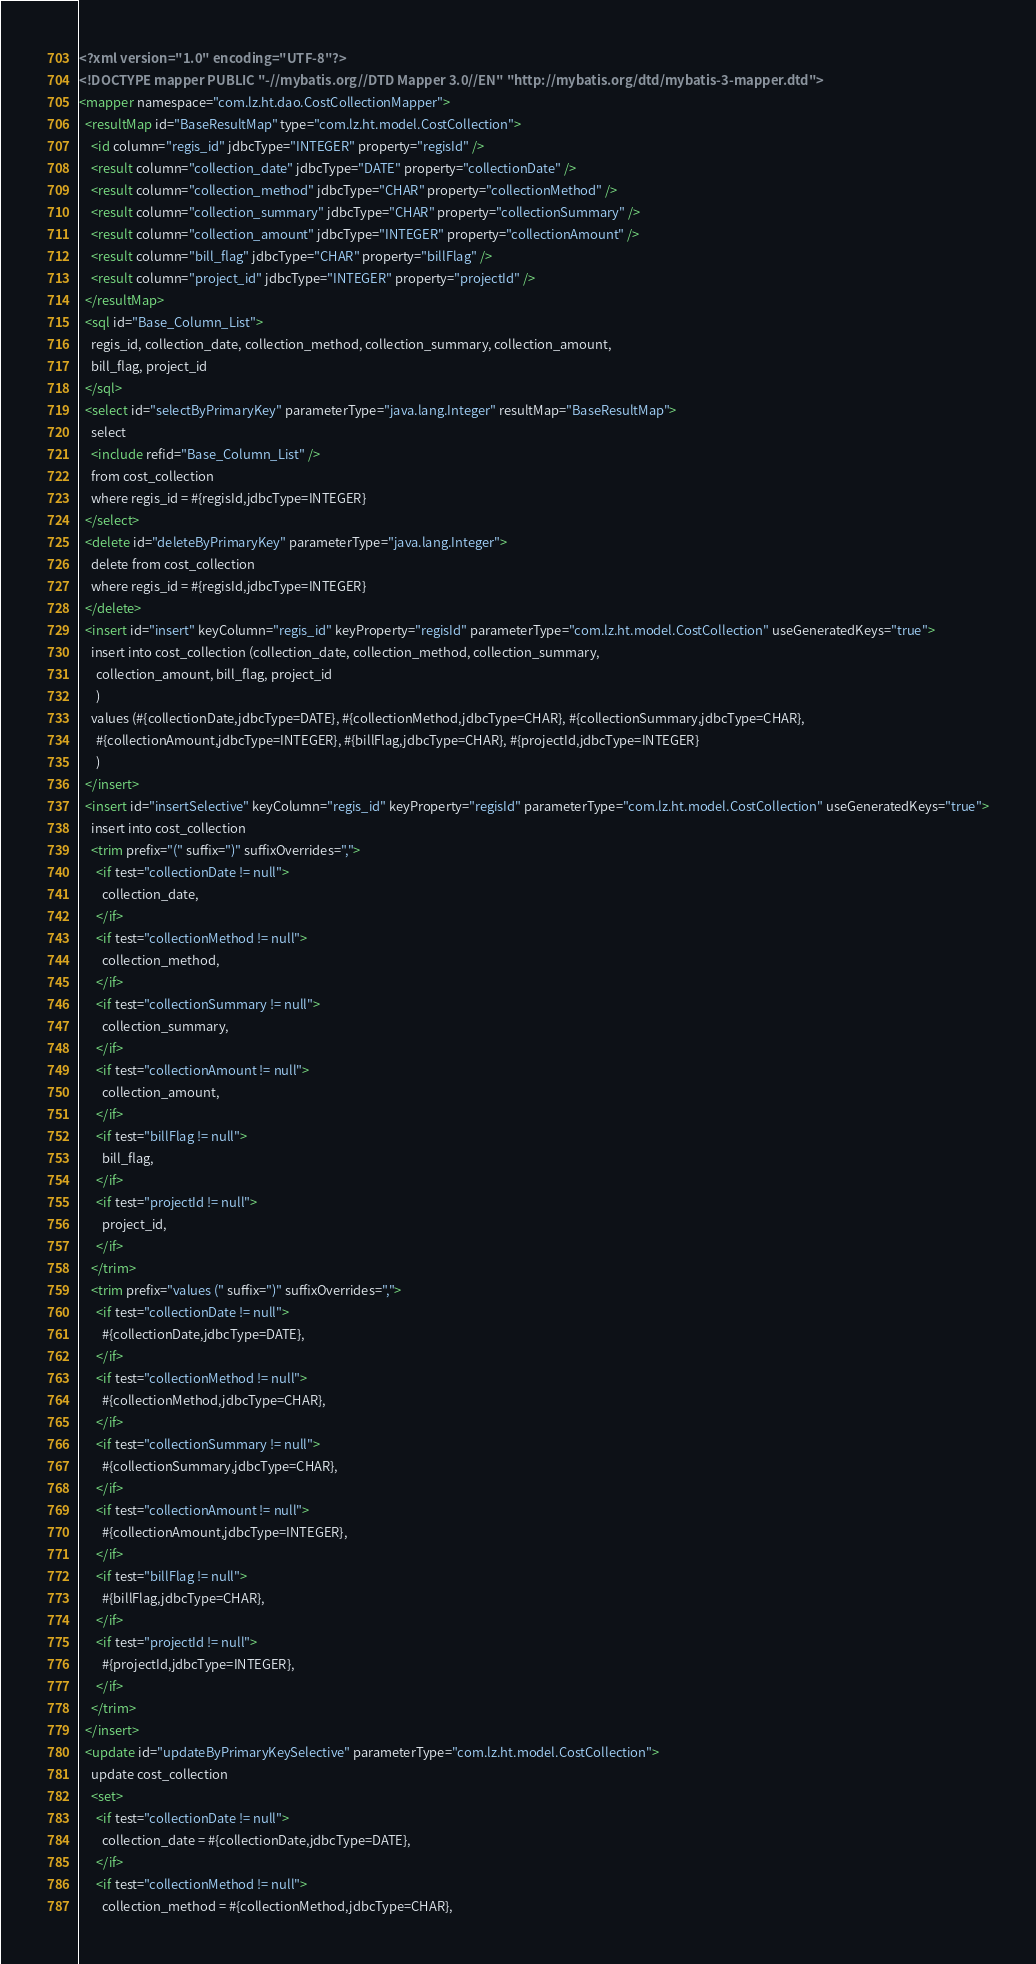Convert code to text. <code><loc_0><loc_0><loc_500><loc_500><_XML_><?xml version="1.0" encoding="UTF-8"?>
<!DOCTYPE mapper PUBLIC "-//mybatis.org//DTD Mapper 3.0//EN" "http://mybatis.org/dtd/mybatis-3-mapper.dtd">
<mapper namespace="com.lz.ht.dao.CostCollectionMapper">
  <resultMap id="BaseResultMap" type="com.lz.ht.model.CostCollection">
    <id column="regis_id" jdbcType="INTEGER" property="regisId" />
    <result column="collection_date" jdbcType="DATE" property="collectionDate" />
    <result column="collection_method" jdbcType="CHAR" property="collectionMethod" />
    <result column="collection_summary" jdbcType="CHAR" property="collectionSummary" />
    <result column="collection_amount" jdbcType="INTEGER" property="collectionAmount" />
    <result column="bill_flag" jdbcType="CHAR" property="billFlag" />
    <result column="project_id" jdbcType="INTEGER" property="projectId" />
  </resultMap>
  <sql id="Base_Column_List">
    regis_id, collection_date, collection_method, collection_summary, collection_amount, 
    bill_flag, project_id
  </sql>
  <select id="selectByPrimaryKey" parameterType="java.lang.Integer" resultMap="BaseResultMap">
    select 
    <include refid="Base_Column_List" />
    from cost_collection
    where regis_id = #{regisId,jdbcType=INTEGER}
  </select>
  <delete id="deleteByPrimaryKey" parameterType="java.lang.Integer">
    delete from cost_collection
    where regis_id = #{regisId,jdbcType=INTEGER}
  </delete>
  <insert id="insert" keyColumn="regis_id" keyProperty="regisId" parameterType="com.lz.ht.model.CostCollection" useGeneratedKeys="true">
    insert into cost_collection (collection_date, collection_method, collection_summary, 
      collection_amount, bill_flag, project_id
      )
    values (#{collectionDate,jdbcType=DATE}, #{collectionMethod,jdbcType=CHAR}, #{collectionSummary,jdbcType=CHAR}, 
      #{collectionAmount,jdbcType=INTEGER}, #{billFlag,jdbcType=CHAR}, #{projectId,jdbcType=INTEGER}
      )
  </insert>
  <insert id="insertSelective" keyColumn="regis_id" keyProperty="regisId" parameterType="com.lz.ht.model.CostCollection" useGeneratedKeys="true">
    insert into cost_collection
    <trim prefix="(" suffix=")" suffixOverrides=",">
      <if test="collectionDate != null">
        collection_date,
      </if>
      <if test="collectionMethod != null">
        collection_method,
      </if>
      <if test="collectionSummary != null">
        collection_summary,
      </if>
      <if test="collectionAmount != null">
        collection_amount,
      </if>
      <if test="billFlag != null">
        bill_flag,
      </if>
      <if test="projectId != null">
        project_id,
      </if>
    </trim>
    <trim prefix="values (" suffix=")" suffixOverrides=",">
      <if test="collectionDate != null">
        #{collectionDate,jdbcType=DATE},
      </if>
      <if test="collectionMethod != null">
        #{collectionMethod,jdbcType=CHAR},
      </if>
      <if test="collectionSummary != null">
        #{collectionSummary,jdbcType=CHAR},
      </if>
      <if test="collectionAmount != null">
        #{collectionAmount,jdbcType=INTEGER},
      </if>
      <if test="billFlag != null">
        #{billFlag,jdbcType=CHAR},
      </if>
      <if test="projectId != null">
        #{projectId,jdbcType=INTEGER},
      </if>
    </trim>
  </insert>
  <update id="updateByPrimaryKeySelective" parameterType="com.lz.ht.model.CostCollection">
    update cost_collection
    <set>
      <if test="collectionDate != null">
        collection_date = #{collectionDate,jdbcType=DATE},
      </if>
      <if test="collectionMethod != null">
        collection_method = #{collectionMethod,jdbcType=CHAR},</code> 